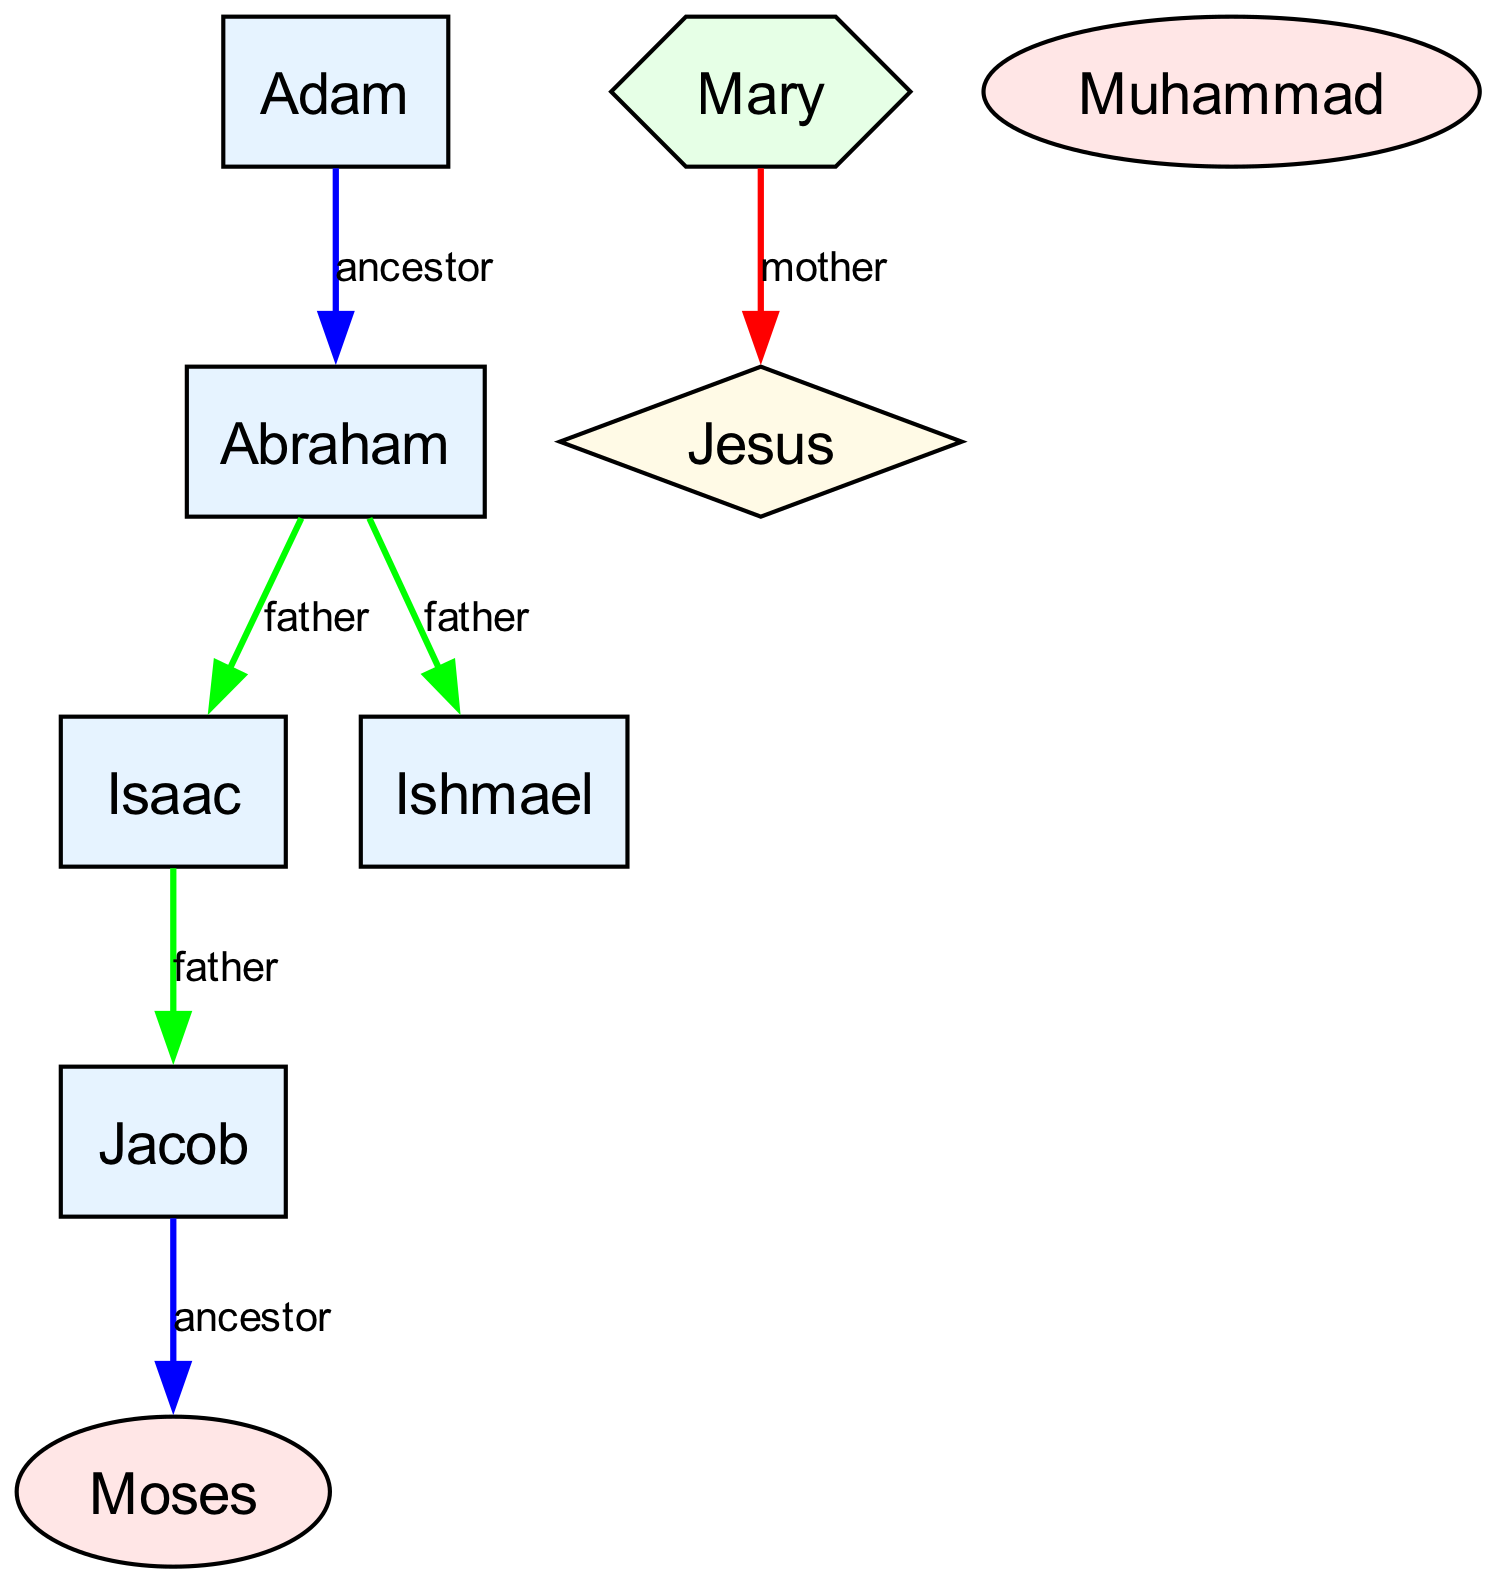What is the total number of nodes in the diagram? Count the number of unique figures represented as nodes in the diagram. There are eight figures listed: Adam, Abraham, Isaac, Ishmael, Jacob, Moses, Jesus, and Mary.
Answer: 8 Who is the mother of Jesus according to the diagram? The relationship indicated in the edges shows that Mary has a direct connection labeled "mother" to Jesus. Therefore, Mary is identified as the mother of Jesus.
Answer: Mary What type of relationship does Abraham have with Isaac? The diagram connects Abraham to Isaac with a relationship labeled "father." This indicates that Abraham is the father of Isaac.
Answer: father How many prophets are represented in the diagram? Identify all nodes that are classified as prophets. The nodes for Moses, Jesus, and Muhammad are all categorized as prophets. Counting these, there are three prophets in total.
Answer: 3 Which prophet is also identified as the Messiah? Examining the nodes, Jesus is specifically marked with the label "prophet/messiah," indicating this dual role. Therefore, Jesus is the individual identified as both a prophet and the Messiah.
Answer: Jesus What relationship exists between Jacob and Moses? The diagram indicates that Jacob is an ancestor of Moses without a direct parent-child link specified. This relationship can be viewed as indirect lineage or ancestral connection.
Answer: ancestor Which figure has a direct connection to both Abraham and Mary? The diagram shows that Jesus is directly connected to Mary (as her son) and is a descendant of Abraham (through the line that includes Isaac and Jacob). Thus, Jesus connects both figures in the family tree.
Answer: Jesus From which patriarch does Moses descend? Tracing upward in the diagram, Moses is connected as a descendant through Jacob, who is ultimately traced back to Abraham. Therefore, the direct patriarchal line can be followed from Jacob to Moses, confirming this descent.
Answer: Jacob 